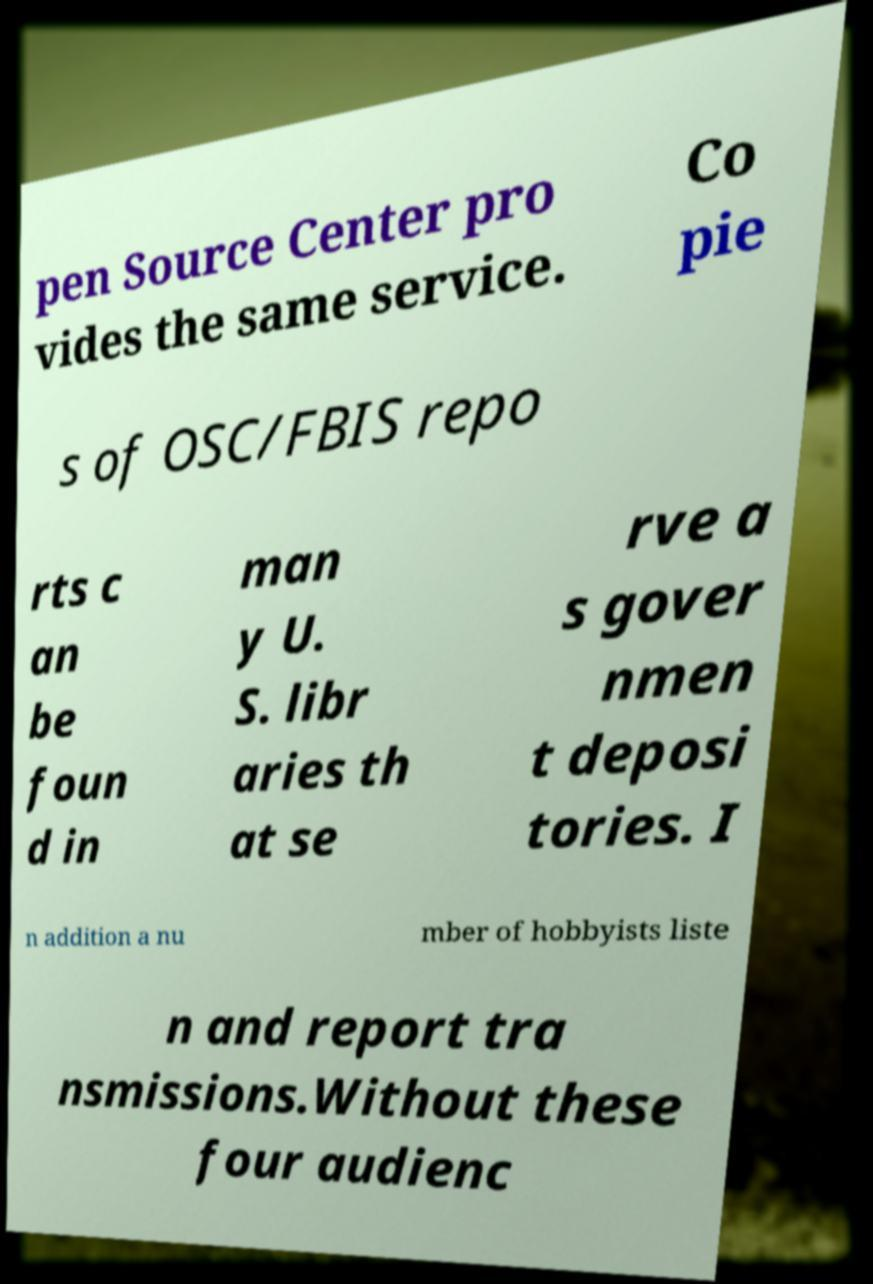Please identify and transcribe the text found in this image. pen Source Center pro vides the same service. Co pie s of OSC/FBIS repo rts c an be foun d in man y U. S. libr aries th at se rve a s gover nmen t deposi tories. I n addition a nu mber of hobbyists liste n and report tra nsmissions.Without these four audienc 